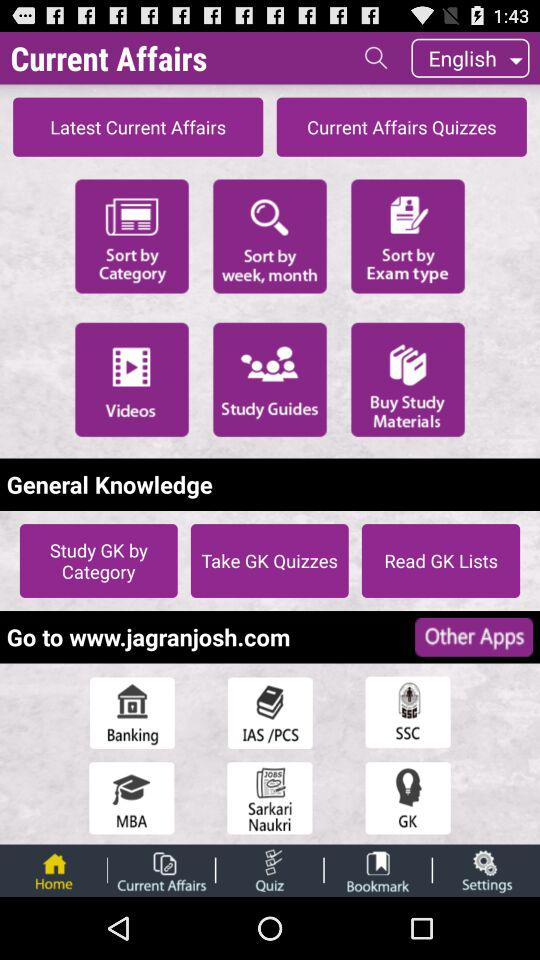Which language is selected? The selected language is English. 